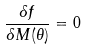<formula> <loc_0><loc_0><loc_500><loc_500>\frac { \delta f } { \delta M ( \theta ) } = 0</formula> 